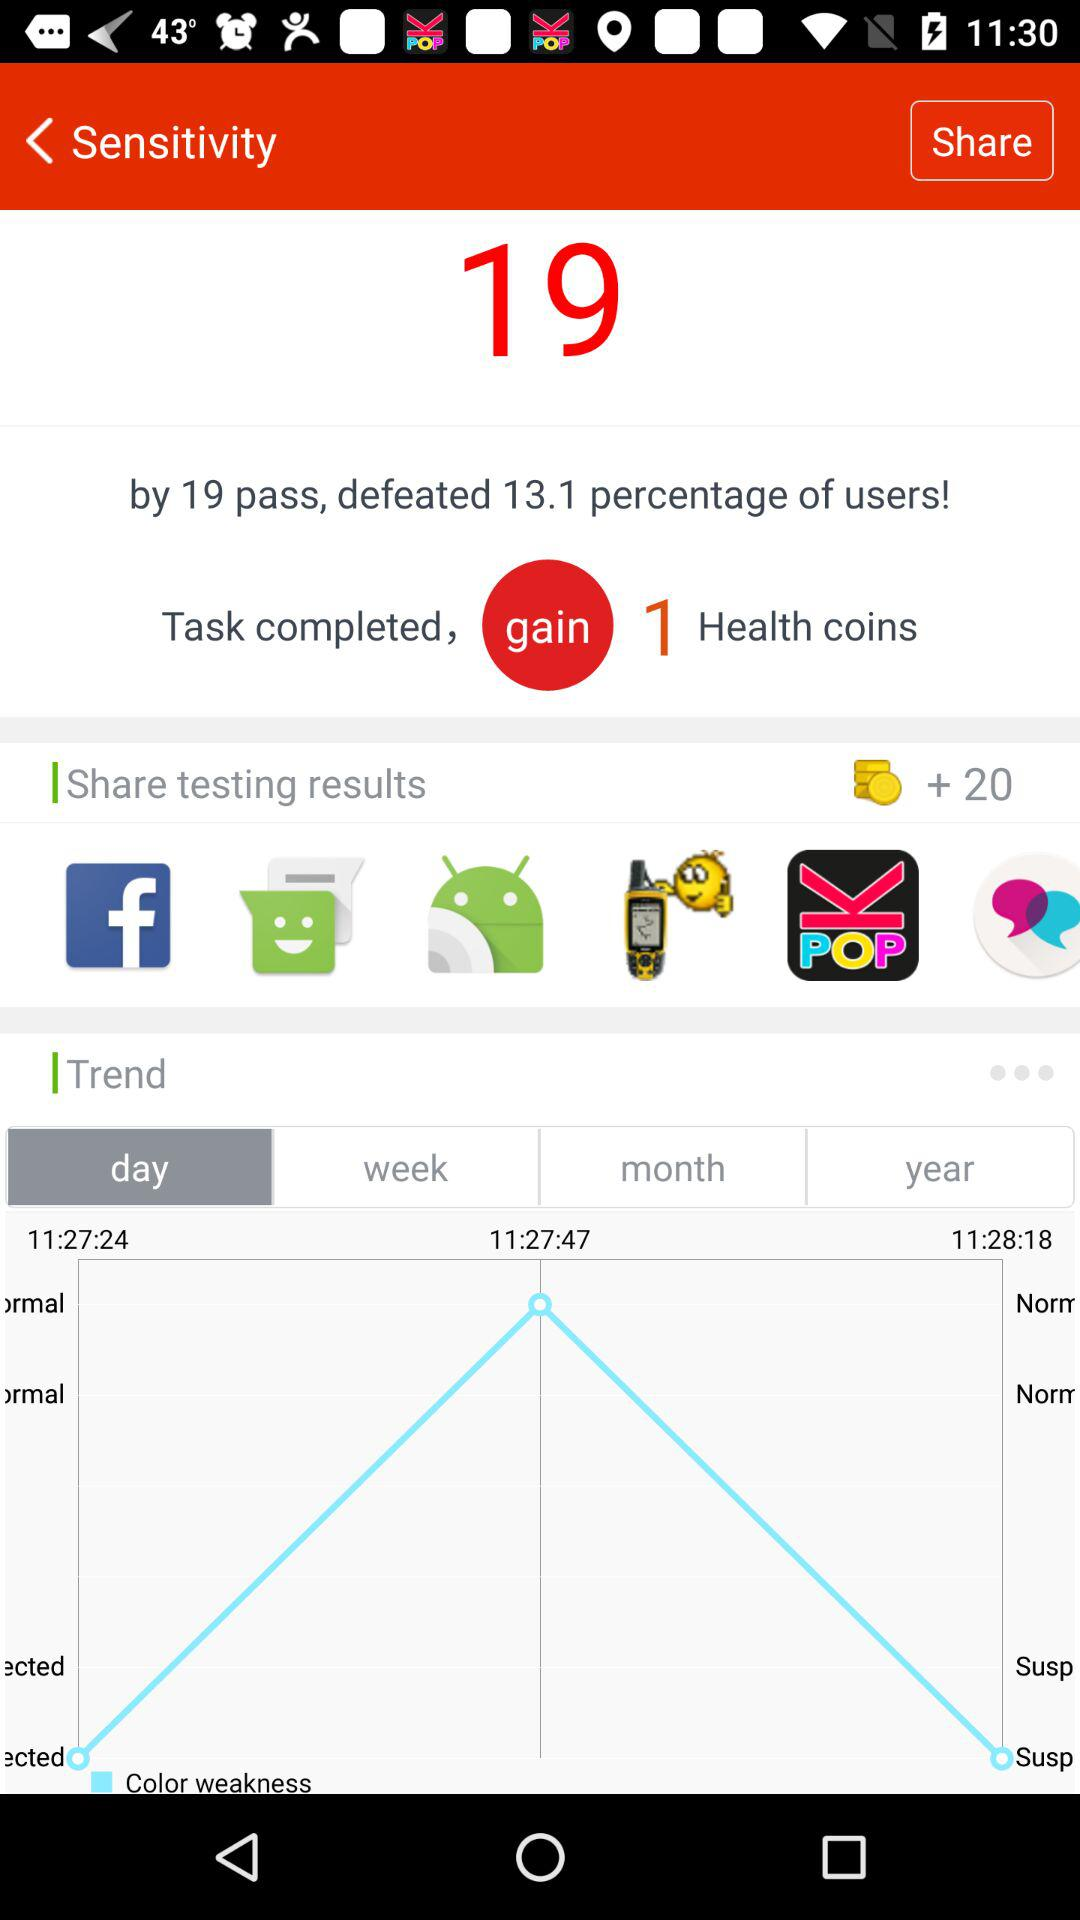How many points are there?
When the provided information is insufficient, respond with <no answer>. <no answer> 